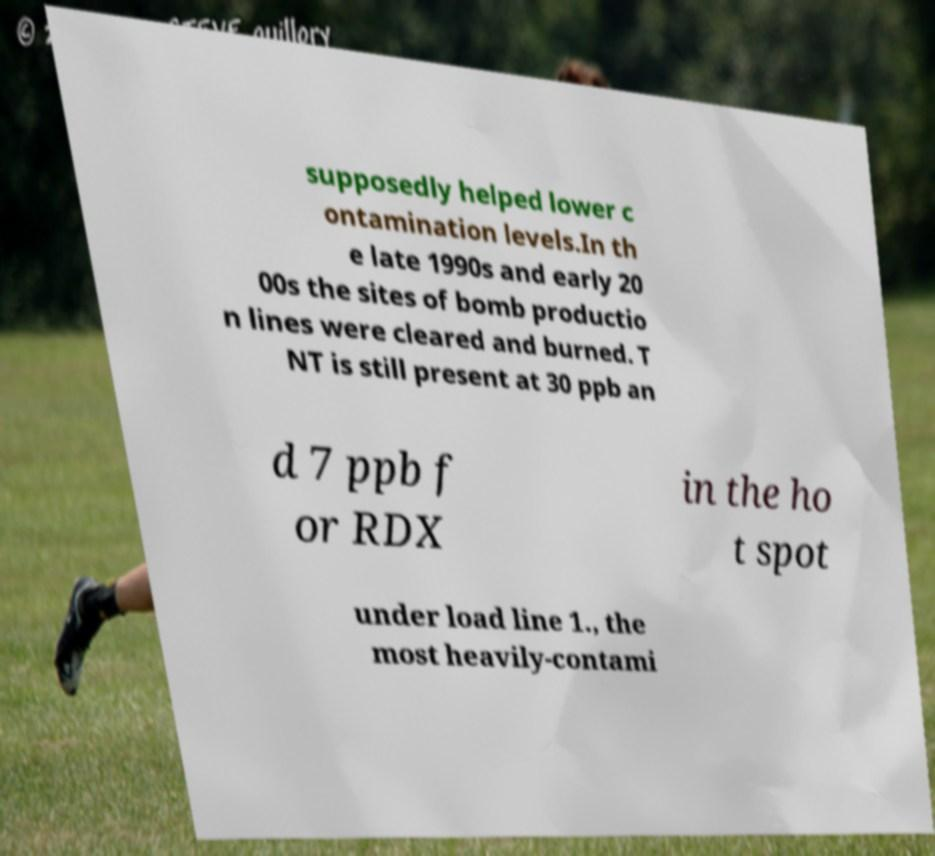Could you extract and type out the text from this image? supposedly helped lower c ontamination levels.In th e late 1990s and early 20 00s the sites of bomb productio n lines were cleared and burned. T NT is still present at 30 ppb an d 7 ppb f or RDX in the ho t spot under load line 1., the most heavily-contami 